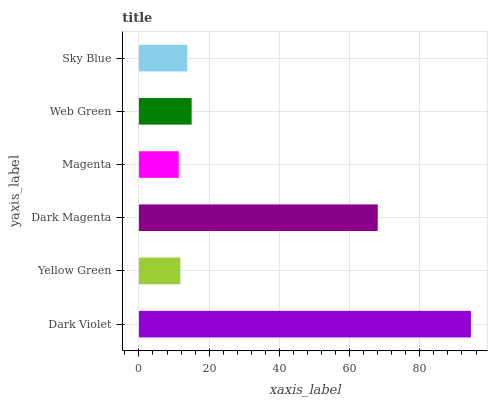Is Magenta the minimum?
Answer yes or no. Yes. Is Dark Violet the maximum?
Answer yes or no. Yes. Is Yellow Green the minimum?
Answer yes or no. No. Is Yellow Green the maximum?
Answer yes or no. No. Is Dark Violet greater than Yellow Green?
Answer yes or no. Yes. Is Yellow Green less than Dark Violet?
Answer yes or no. Yes. Is Yellow Green greater than Dark Violet?
Answer yes or no. No. Is Dark Violet less than Yellow Green?
Answer yes or no. No. Is Web Green the high median?
Answer yes or no. Yes. Is Sky Blue the low median?
Answer yes or no. Yes. Is Magenta the high median?
Answer yes or no. No. Is Magenta the low median?
Answer yes or no. No. 